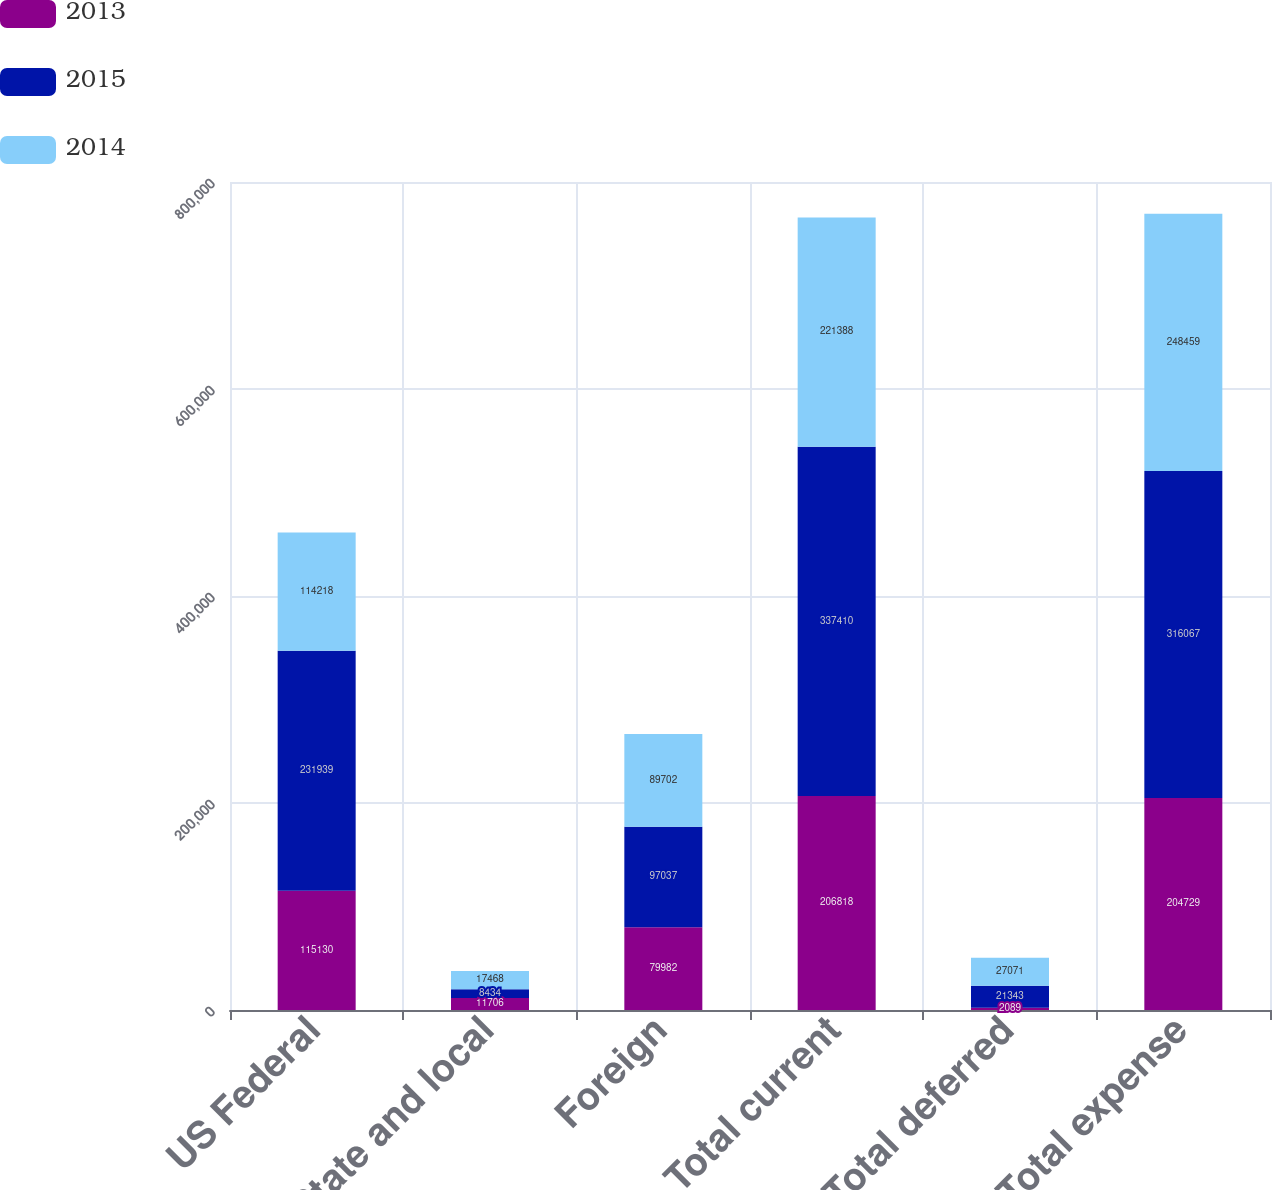Convert chart. <chart><loc_0><loc_0><loc_500><loc_500><stacked_bar_chart><ecel><fcel>US Federal<fcel>State and local<fcel>Foreign<fcel>Total current<fcel>Total deferred<fcel>Total expense<nl><fcel>2013<fcel>115130<fcel>11706<fcel>79982<fcel>206818<fcel>2089<fcel>204729<nl><fcel>2015<fcel>231939<fcel>8434<fcel>97037<fcel>337410<fcel>21343<fcel>316067<nl><fcel>2014<fcel>114218<fcel>17468<fcel>89702<fcel>221388<fcel>27071<fcel>248459<nl></chart> 